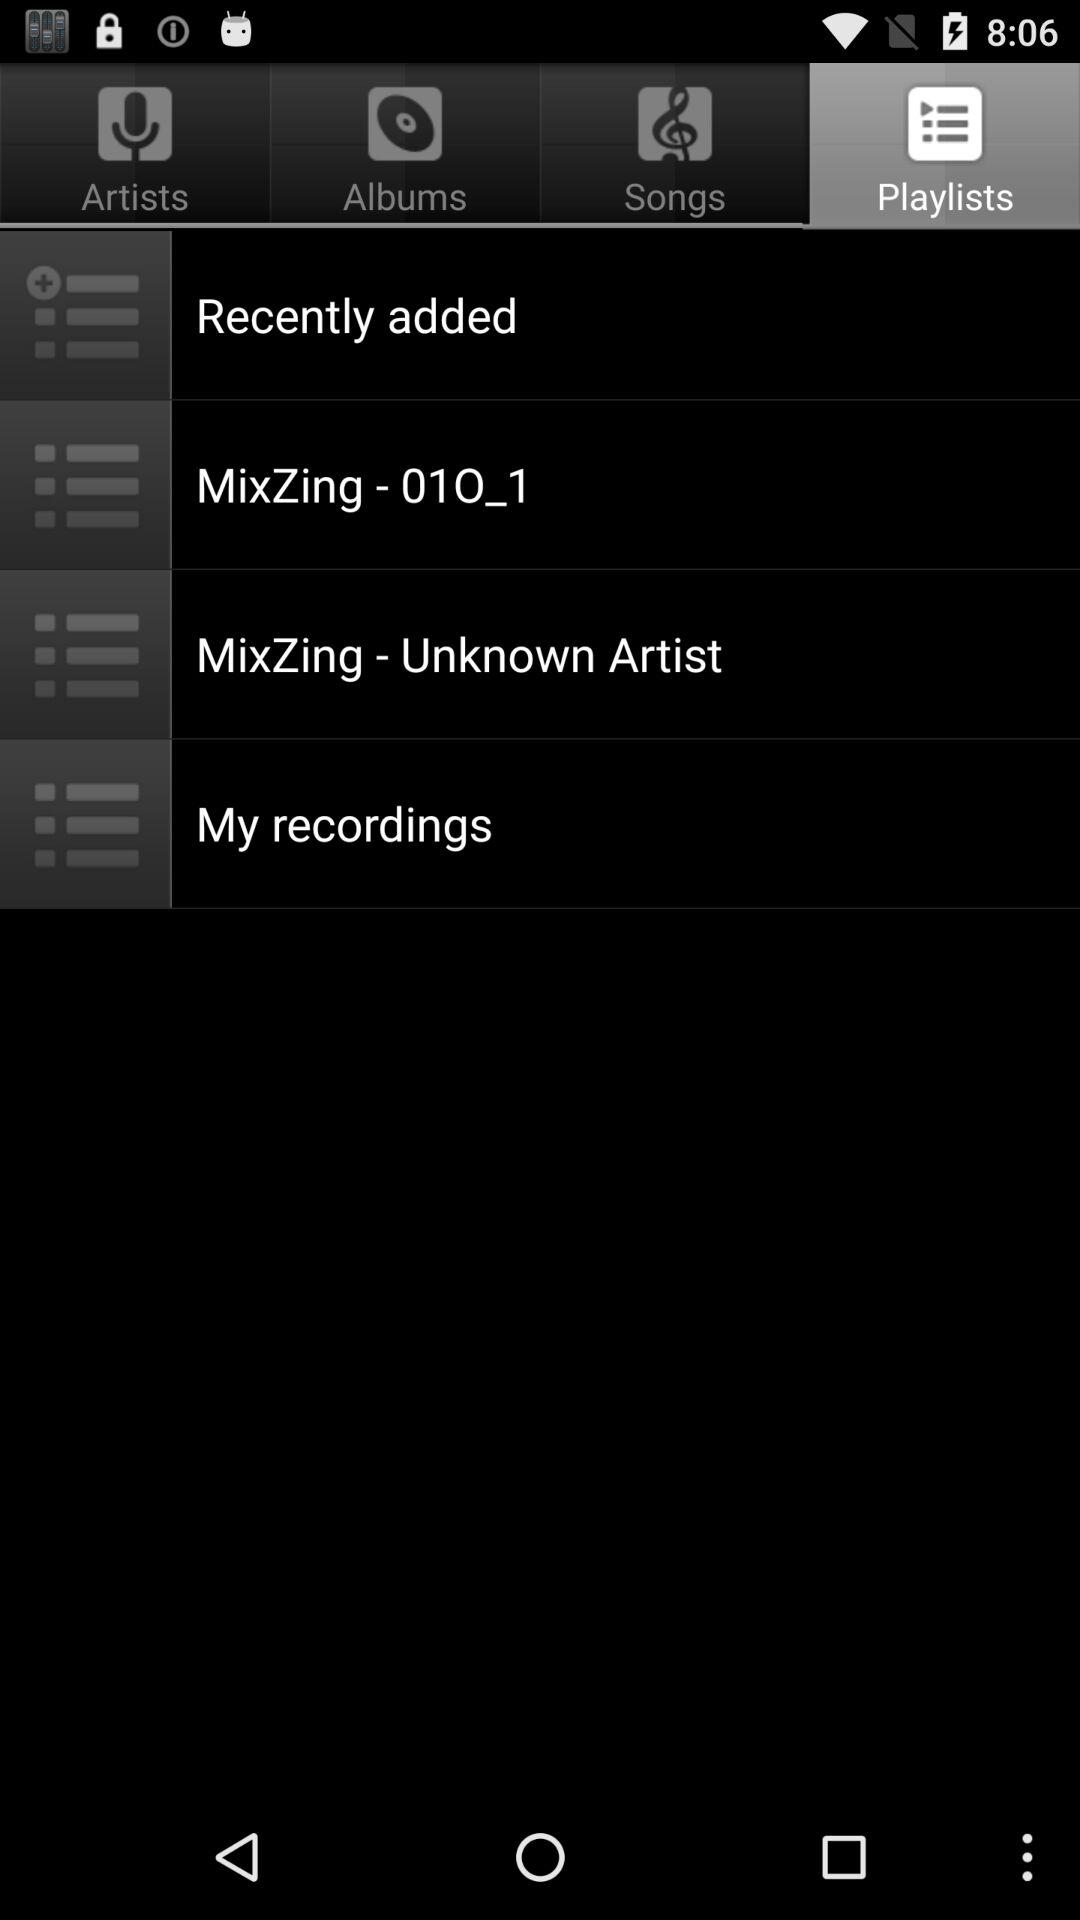Which tab is selected? The selected tab is "Playlists". 